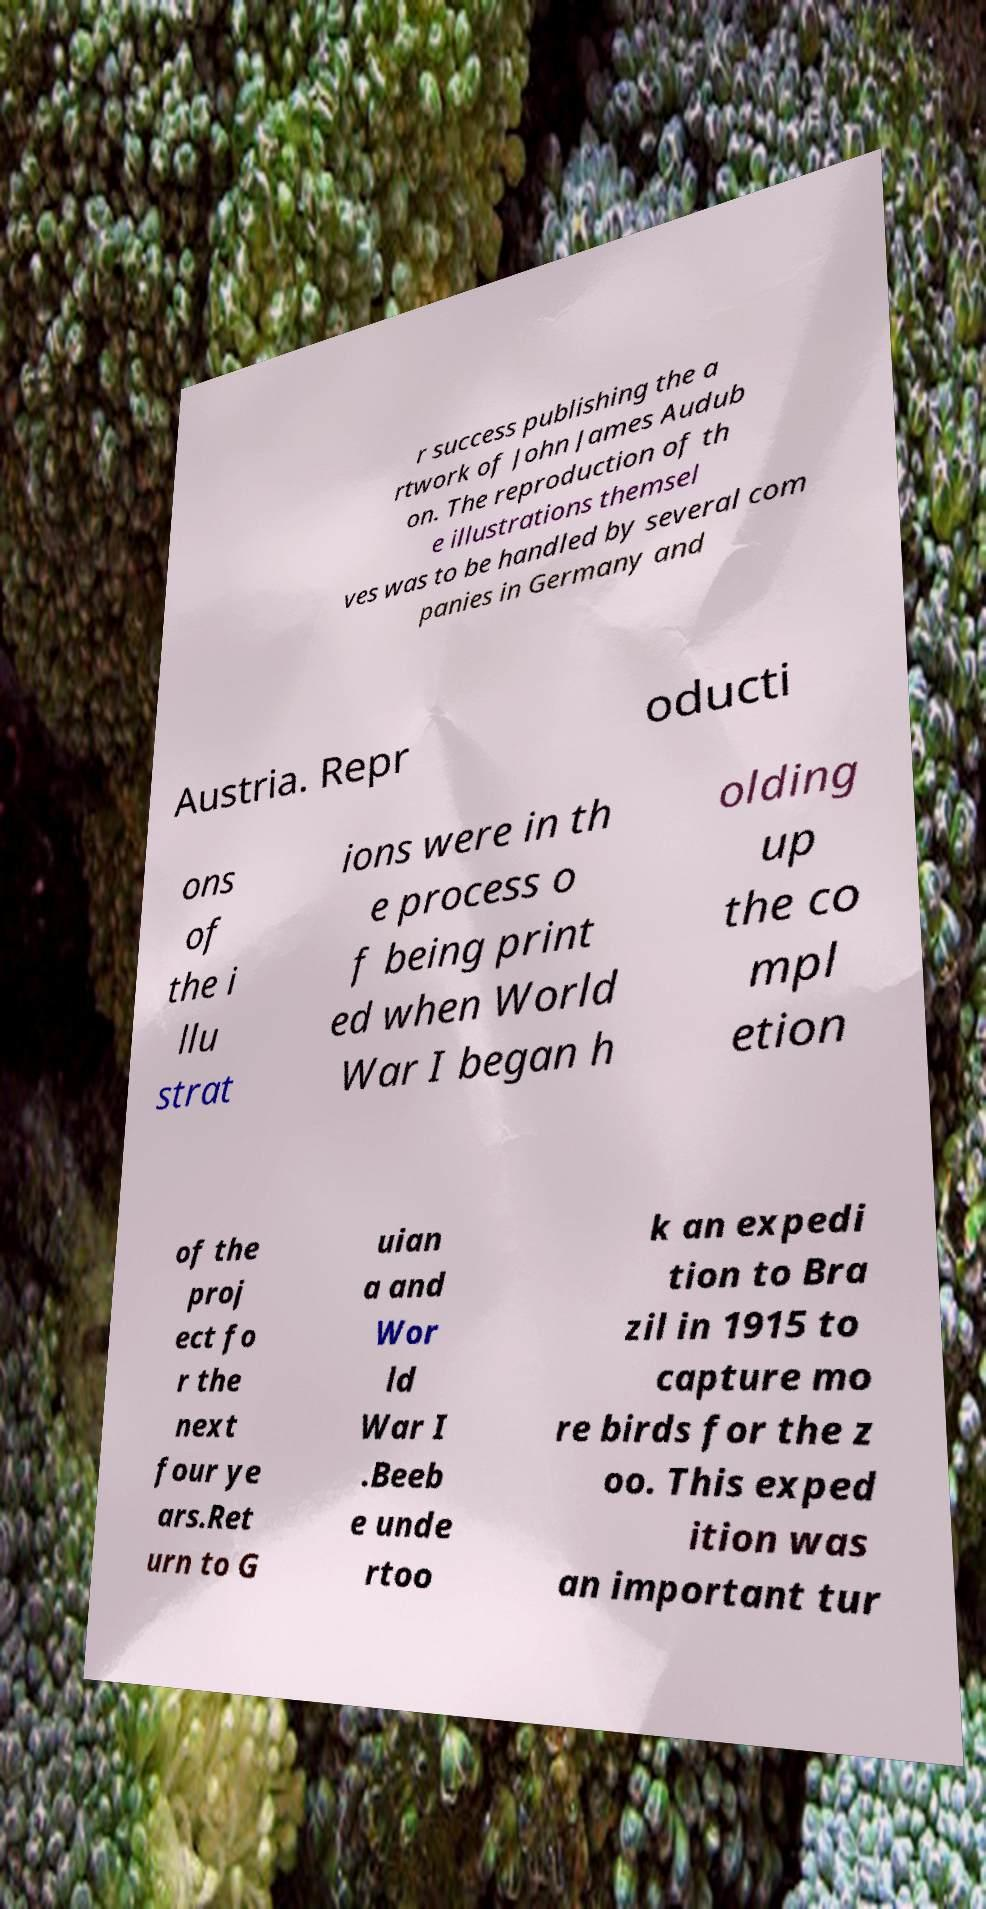Can you accurately transcribe the text from the provided image for me? r success publishing the a rtwork of John James Audub on. The reproduction of th e illustrations themsel ves was to be handled by several com panies in Germany and Austria. Repr oducti ons of the i llu strat ions were in th e process o f being print ed when World War I began h olding up the co mpl etion of the proj ect fo r the next four ye ars.Ret urn to G uian a and Wor ld War I .Beeb e unde rtoo k an expedi tion to Bra zil in 1915 to capture mo re birds for the z oo. This exped ition was an important tur 